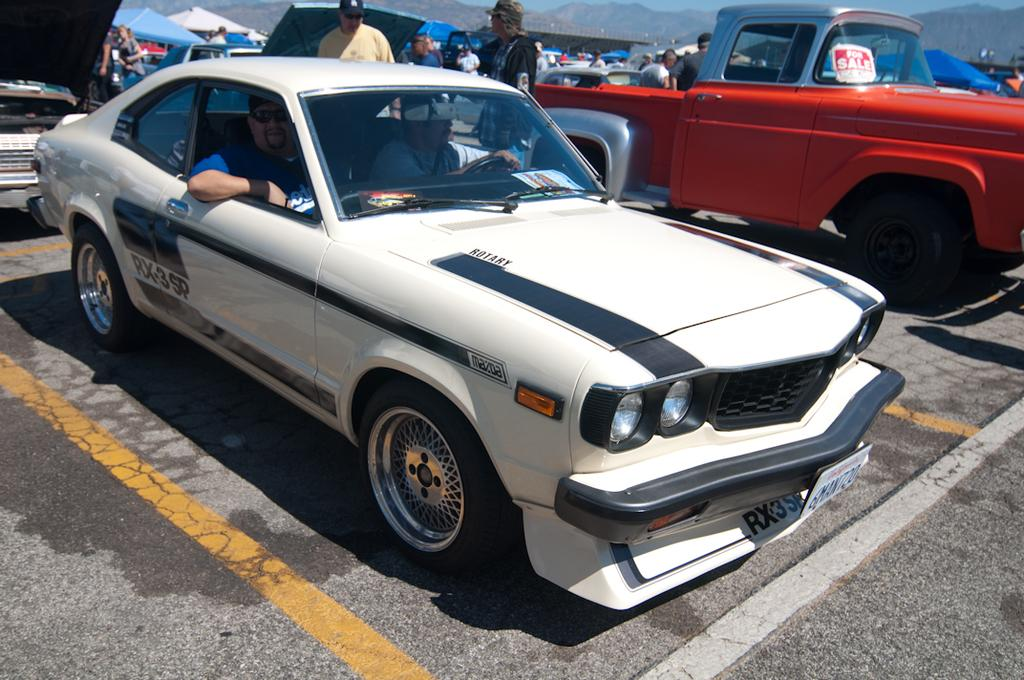What type of vehicles can be seen in the image? There are cars in the image. What type of temporary shelters are present in the image? There are tents in the image. Can you describe the people in the image? There are people in the image. What can be seen in the distance in the background of the image? There are mountains and sky visible in the background of the image. What is the primary means of transportation in the image? There is a road in the image. What type of zinc is present in the image? There is no zinc present in the image. Can you describe the woman in the image? There is no woman specifically mentioned in the provided facts, so we cannot answer this question. 